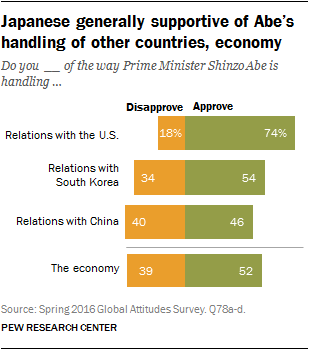Outline some significant characteristics in this image. According to a recent survey, 52% of Japanese approve of the way Prime Minister Shinzo Abe is handling the economy. Out of the three green bars that have a value above 50, which one is the highest? 